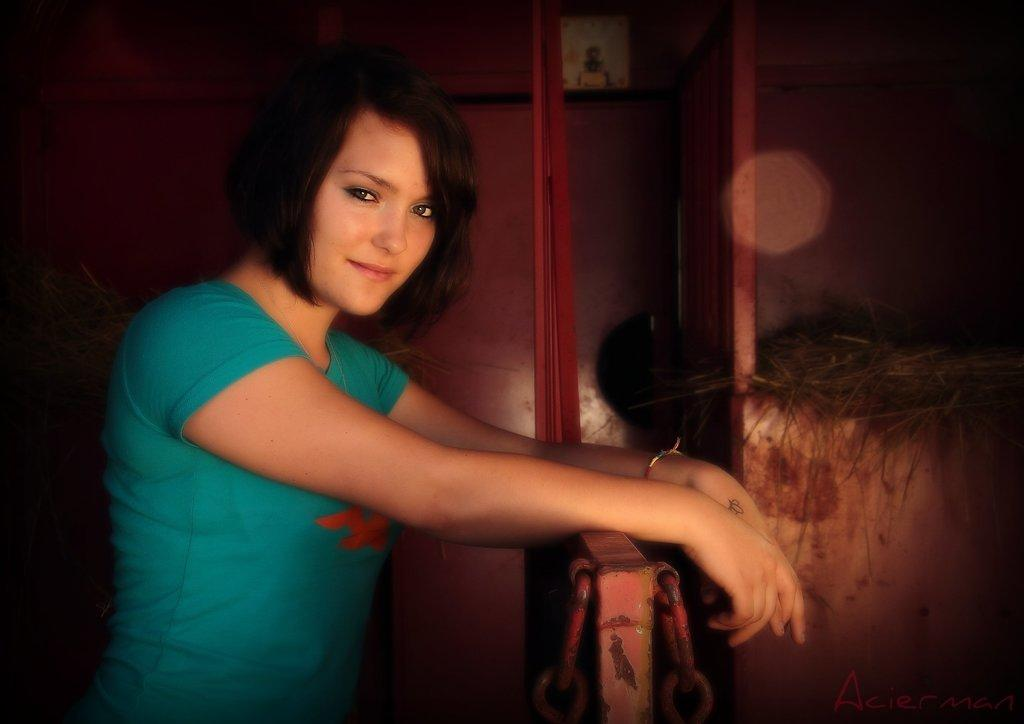Who is present in the image? There is a lady in the image. What is the lady doing in the image? The lady is standing and smiling. What can be seen in the background of the image? There is a wall and grass visible in the background of the image. What architectural feature is present at the bottom of the image? There is a gate at the bottom of the image. What type of mitten is the lady wearing in the image? The lady is not wearing a mitten in the image; she is not holding or wearing any gloves or mittens. How does the acoustics of the lady's voice change when she smiles in the image? The image does not provide any information about the lady's voice or the acoustics of the environment, so we cannot determine how her voice changes when she smiles. 